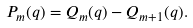<formula> <loc_0><loc_0><loc_500><loc_500>P _ { m } ( q ) = Q _ { m } ( q ) - Q _ { m + 1 } ( q ) .</formula> 